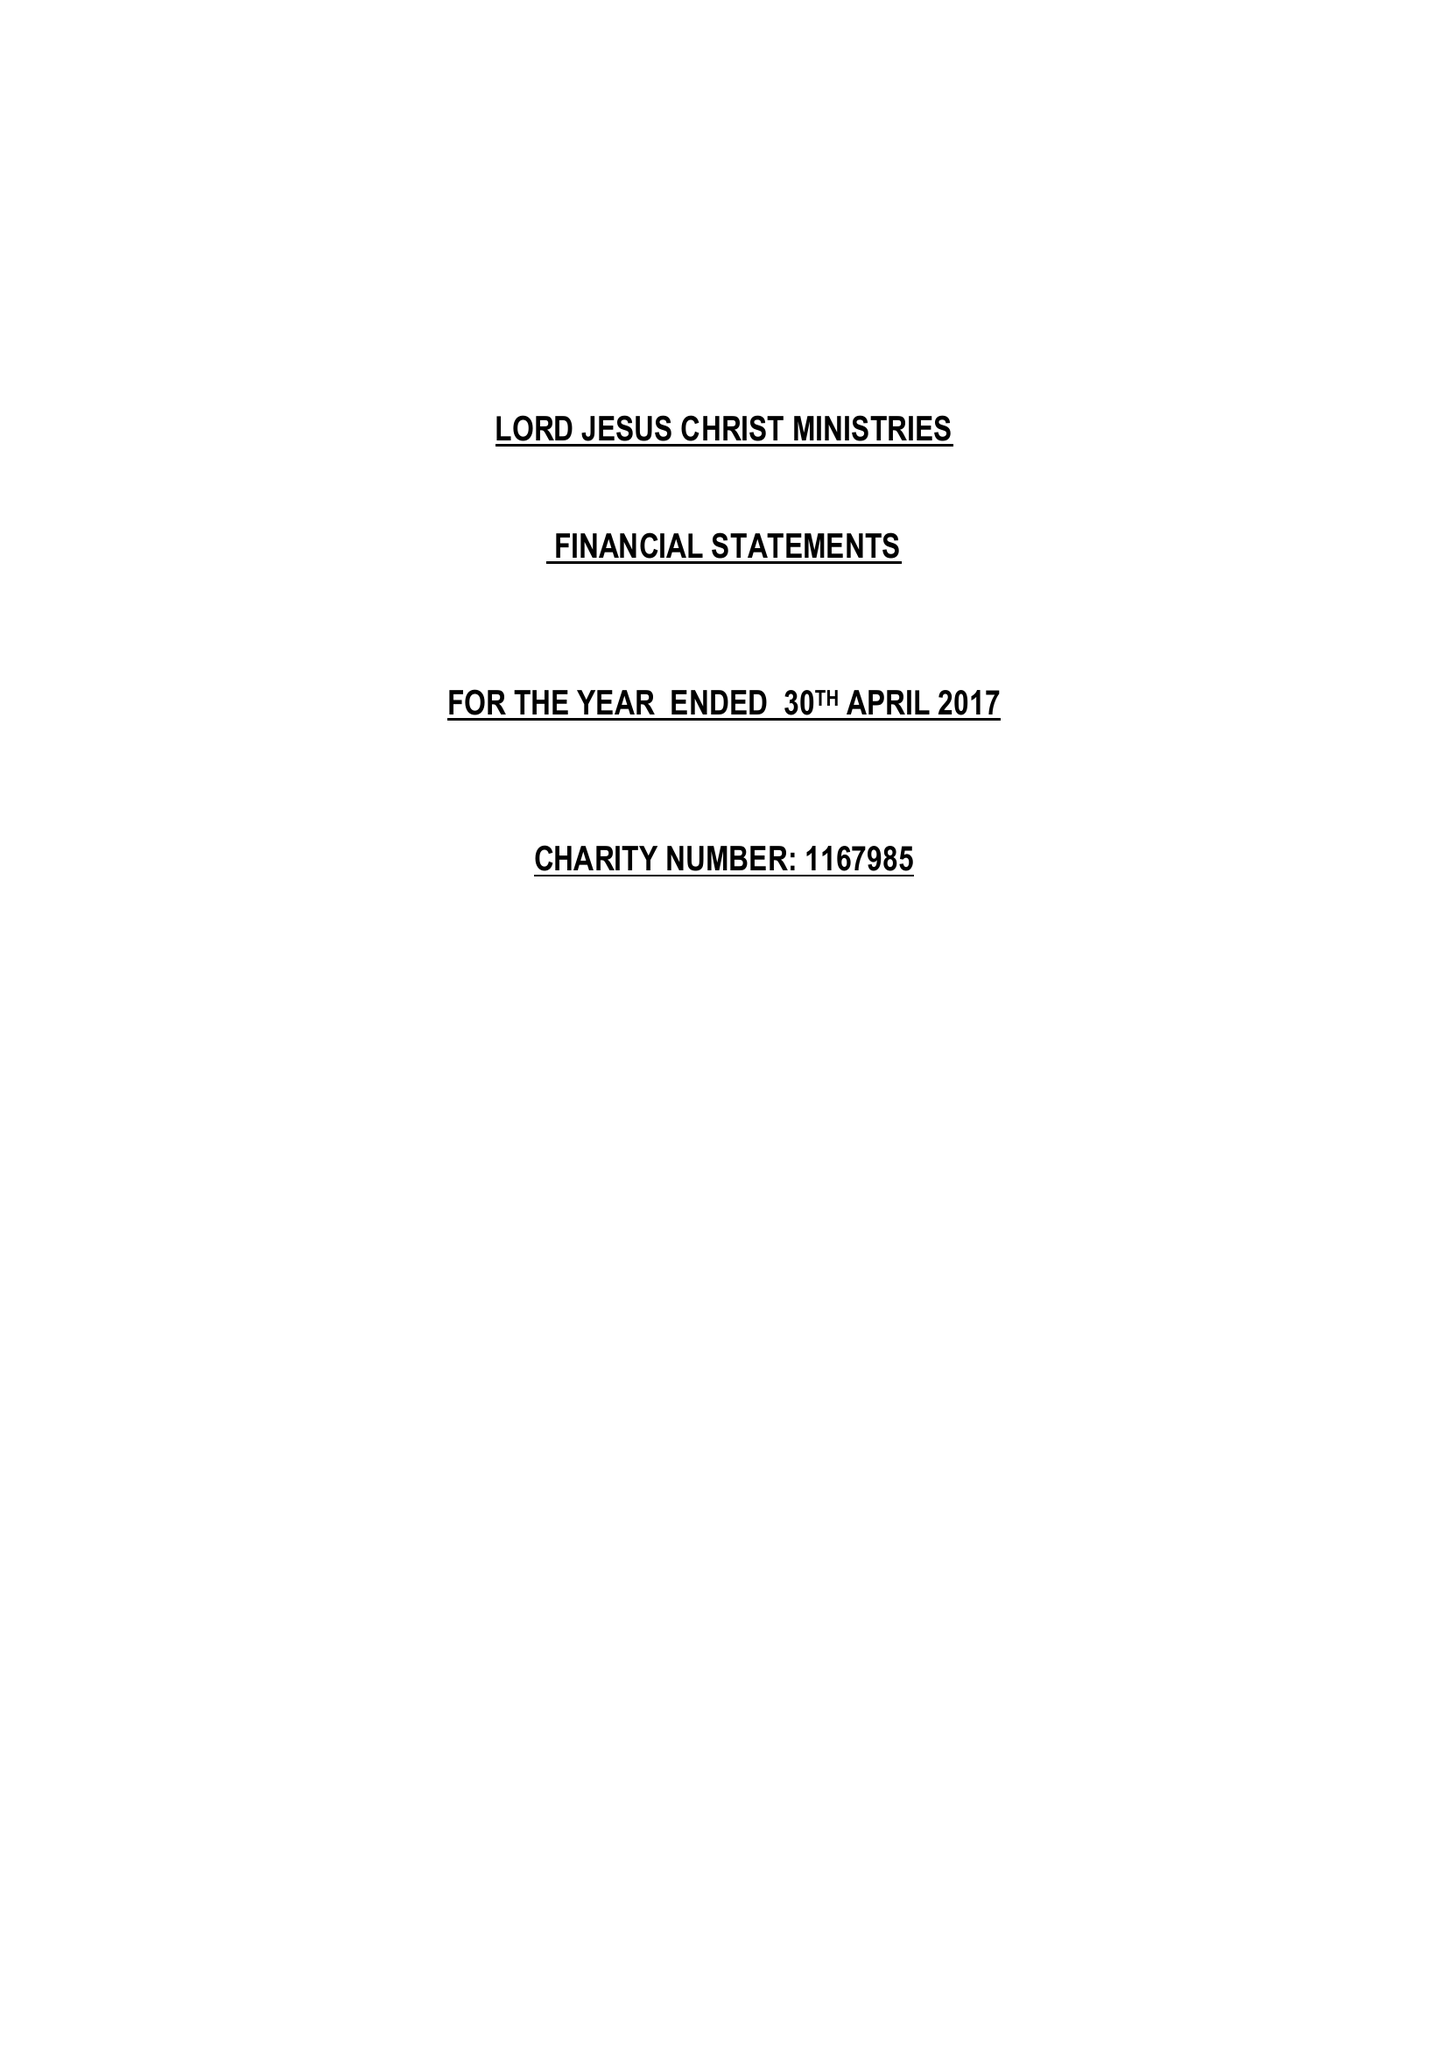What is the value for the income_annually_in_british_pounds?
Answer the question using a single word or phrase. 2407.00 